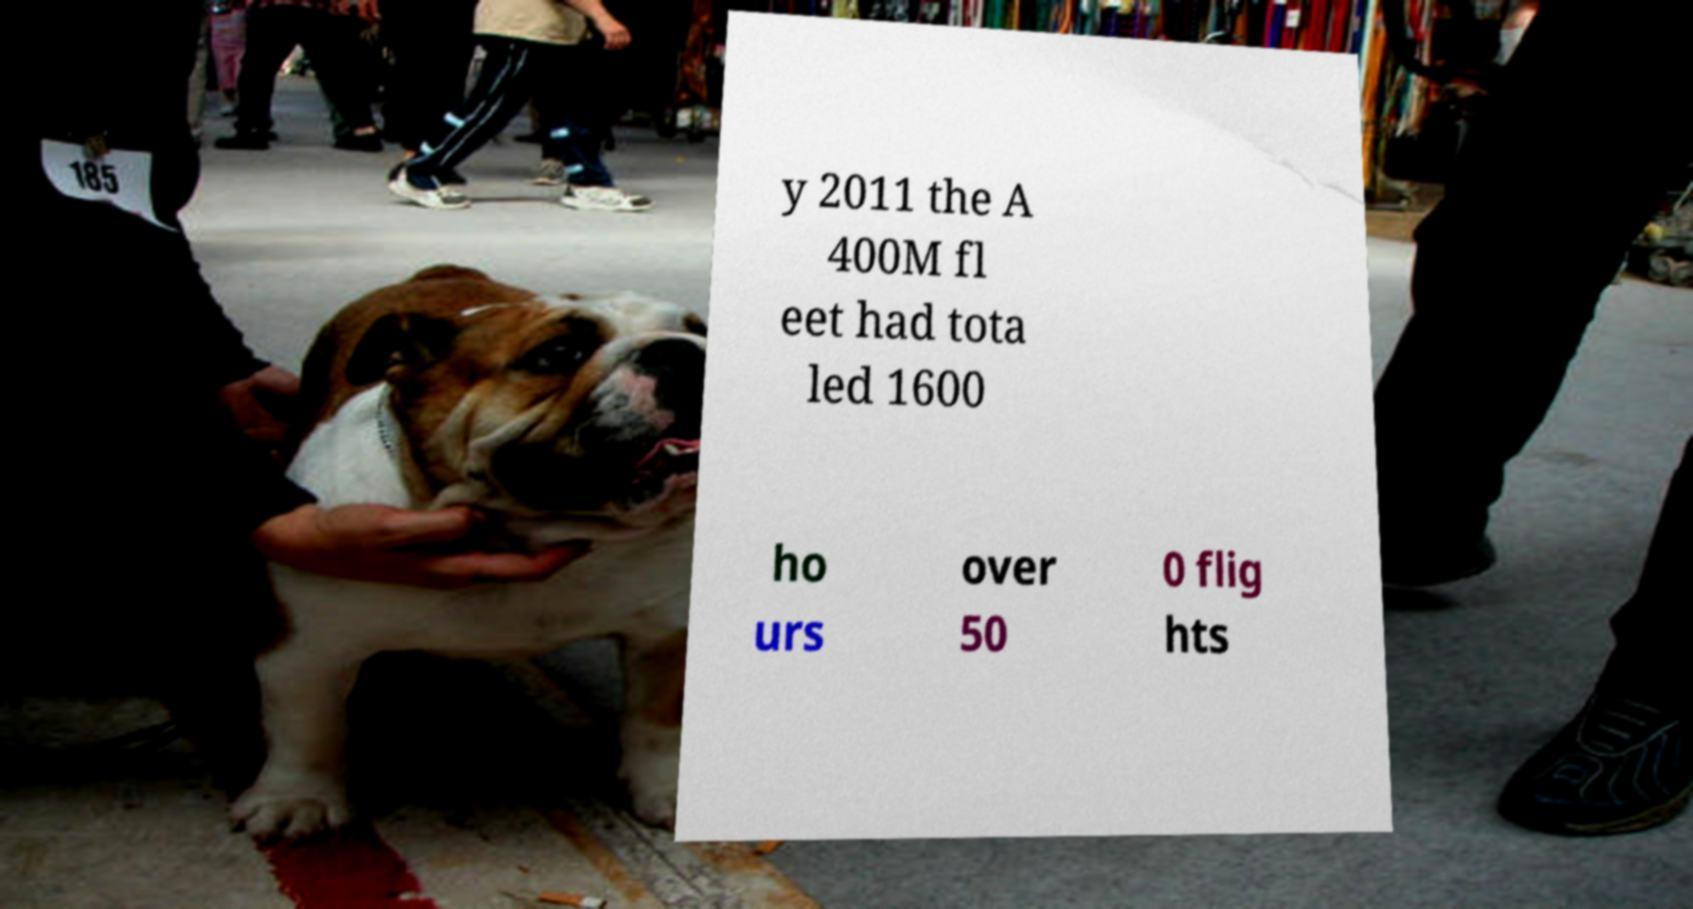For documentation purposes, I need the text within this image transcribed. Could you provide that? y 2011 the A 400M fl eet had tota led 1600 ho urs over 50 0 flig hts 